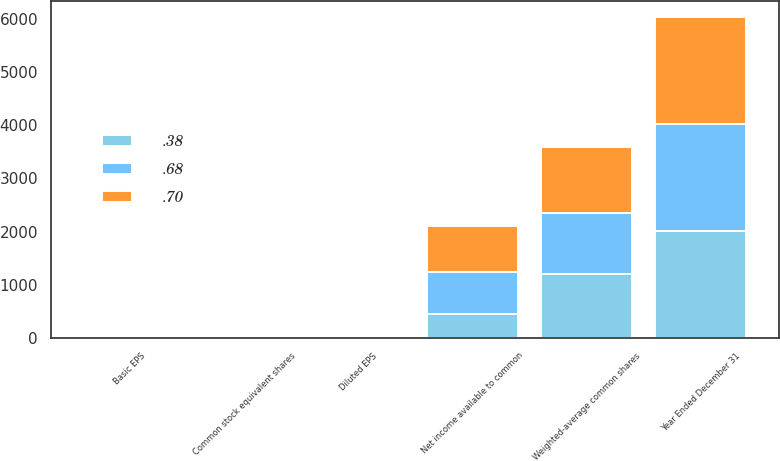<chart> <loc_0><loc_0><loc_500><loc_500><stacked_bar_chart><ecel><fcel>Year Ended December 31<fcel>Net income available to common<fcel>Weighted-average common shares<fcel>Common stock equivalent shares<fcel>Basic EPS<fcel>Diluted EPS<nl><fcel>0.7<fcel>2011<fcel>864<fcel>1229<fcel>2<fcel>0.7<fcel>0.7<nl><fcel>0.38<fcel>2010<fcel>454<fcel>1194<fcel>3<fcel>0.38<fcel>0.38<nl><fcel>0.68<fcel>2009<fcel>787<fcel>1160<fcel>4<fcel>0.68<fcel>0.68<nl></chart> 